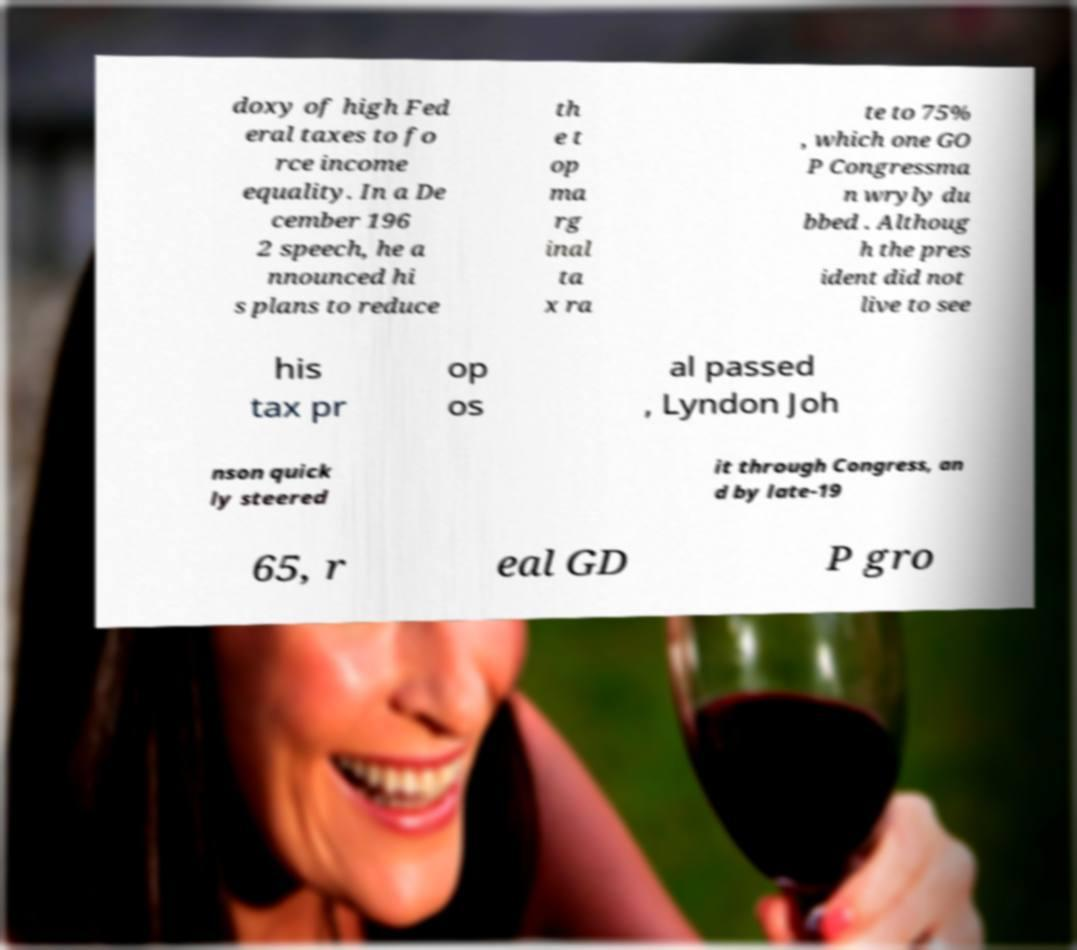Please read and relay the text visible in this image. What does it say? doxy of high Fed eral taxes to fo rce income equality. In a De cember 196 2 speech, he a nnounced hi s plans to reduce th e t op ma rg inal ta x ra te to 75% , which one GO P Congressma n wryly du bbed . Althoug h the pres ident did not live to see his tax pr op os al passed , Lyndon Joh nson quick ly steered it through Congress, an d by late-19 65, r eal GD P gro 